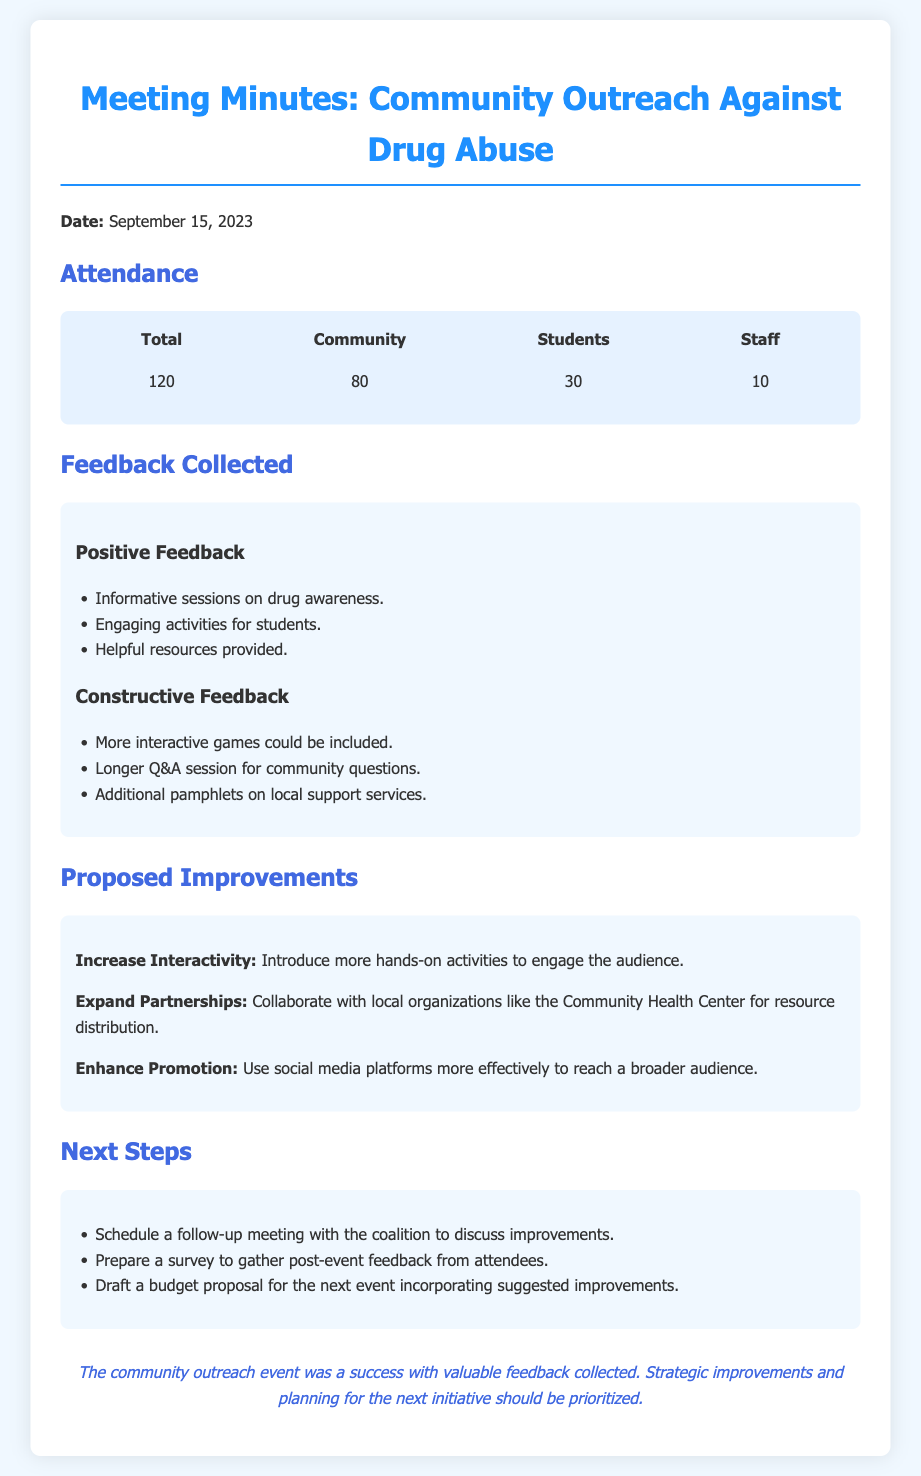what was the date of the meeting? The date of the meeting is specified at the beginning of the document.
Answer: September 15, 2023 how many total attendees were there? The total number of attendees is listed under the attendance section of the document.
Answer: 120 what percentage of attendees were students? This requires calculating the percentage based on the attendance numbers provided: (30 students / 120 total attendees) * 100.
Answer: 25% what was one piece of constructive feedback? The document lists specific constructive feedback under the feedback section.
Answer: More interactive games could be included what is one proposed improvement for future initiatives? This can be found in the proposed improvements section of the document, which outlines suggestions.
Answer: Increase Interactivity how many staff members attended the event? The number of staff members is mentioned in the attendance breakdown within the document.
Answer: 10 how many community members attended? The number of community members is also specified in the attendance section.
Answer: 80 what is one next step mentioned after the meeting? The next steps to be taken following the meeting are listed in a specific section of the document.
Answer: Schedule a follow-up meeting with the coalition to discuss improvements 